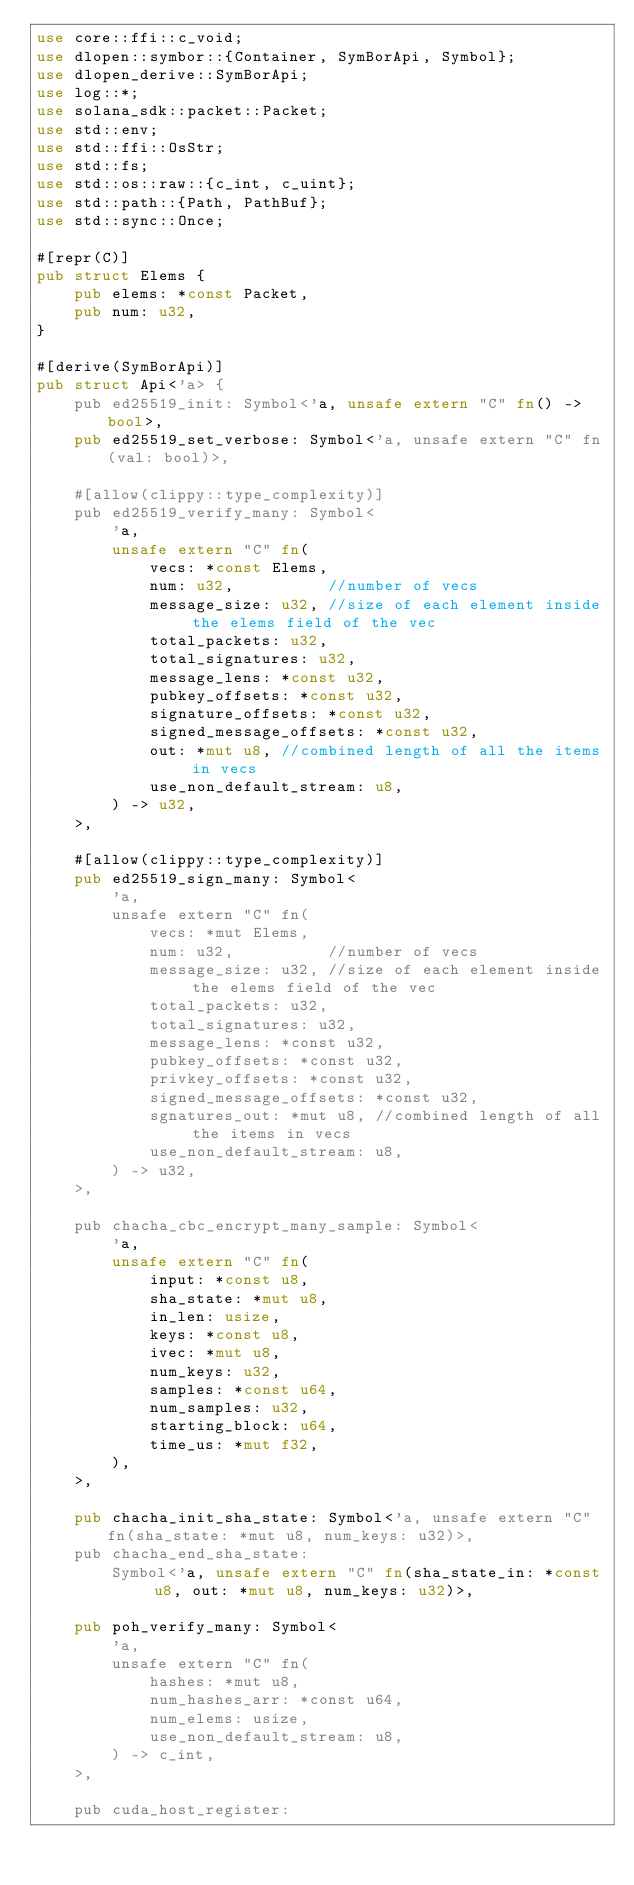<code> <loc_0><loc_0><loc_500><loc_500><_Rust_>use core::ffi::c_void;
use dlopen::symbor::{Container, SymBorApi, Symbol};
use dlopen_derive::SymBorApi;
use log::*;
use solana_sdk::packet::Packet;
use std::env;
use std::ffi::OsStr;
use std::fs;
use std::os::raw::{c_int, c_uint};
use std::path::{Path, PathBuf};
use std::sync::Once;

#[repr(C)]
pub struct Elems {
    pub elems: *const Packet,
    pub num: u32,
}

#[derive(SymBorApi)]
pub struct Api<'a> {
    pub ed25519_init: Symbol<'a, unsafe extern "C" fn() -> bool>,
    pub ed25519_set_verbose: Symbol<'a, unsafe extern "C" fn(val: bool)>,

    #[allow(clippy::type_complexity)]
    pub ed25519_verify_many: Symbol<
        'a,
        unsafe extern "C" fn(
            vecs: *const Elems,
            num: u32,          //number of vecs
            message_size: u32, //size of each element inside the elems field of the vec
            total_packets: u32,
            total_signatures: u32,
            message_lens: *const u32,
            pubkey_offsets: *const u32,
            signature_offsets: *const u32,
            signed_message_offsets: *const u32,
            out: *mut u8, //combined length of all the items in vecs
            use_non_default_stream: u8,
        ) -> u32,
    >,

    #[allow(clippy::type_complexity)]
    pub ed25519_sign_many: Symbol<
        'a,
        unsafe extern "C" fn(
            vecs: *mut Elems,
            num: u32,          //number of vecs
            message_size: u32, //size of each element inside the elems field of the vec
            total_packets: u32,
            total_signatures: u32,
            message_lens: *const u32,
            pubkey_offsets: *const u32,
            privkey_offsets: *const u32,
            signed_message_offsets: *const u32,
            sgnatures_out: *mut u8, //combined length of all the items in vecs
            use_non_default_stream: u8,
        ) -> u32,
    >,

    pub chacha_cbc_encrypt_many_sample: Symbol<
        'a,
        unsafe extern "C" fn(
            input: *const u8,
            sha_state: *mut u8,
            in_len: usize,
            keys: *const u8,
            ivec: *mut u8,
            num_keys: u32,
            samples: *const u64,
            num_samples: u32,
            starting_block: u64,
            time_us: *mut f32,
        ),
    >,

    pub chacha_init_sha_state: Symbol<'a, unsafe extern "C" fn(sha_state: *mut u8, num_keys: u32)>,
    pub chacha_end_sha_state:
        Symbol<'a, unsafe extern "C" fn(sha_state_in: *const u8, out: *mut u8, num_keys: u32)>,

    pub poh_verify_many: Symbol<
        'a,
        unsafe extern "C" fn(
            hashes: *mut u8,
            num_hashes_arr: *const u64,
            num_elems: usize,
            use_non_default_stream: u8,
        ) -> c_int,
    >,

    pub cuda_host_register:</code> 